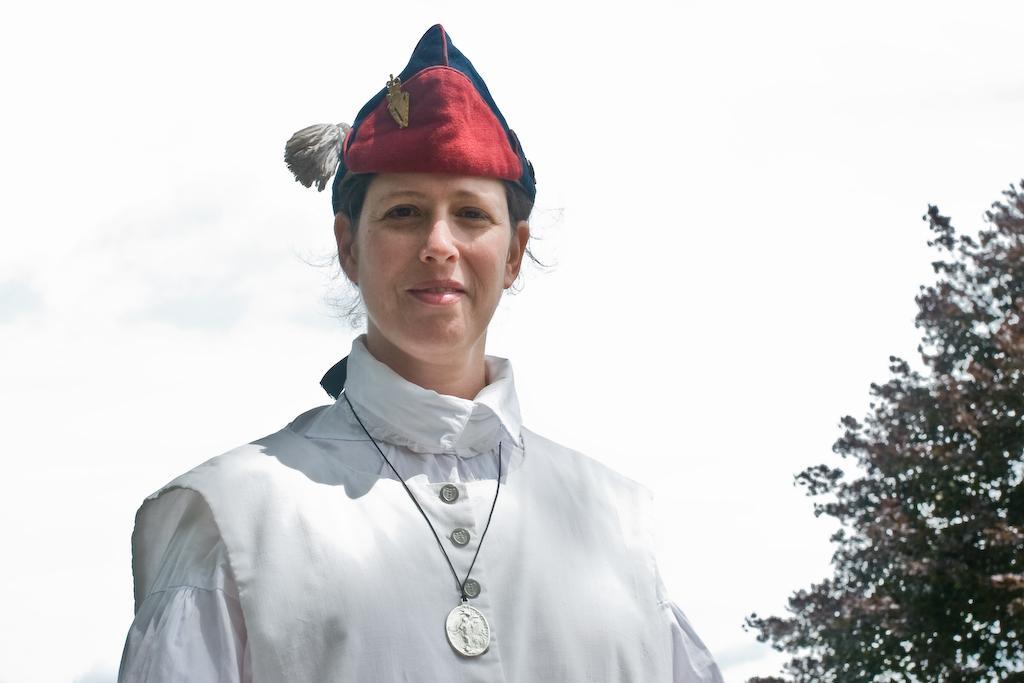Could you give a brief overview of what you see in this image? In this image I can see a woman wearing white color dress, smiling and giving pose for the picture. On the right side there is a tree. In the background, I can see the sky. 